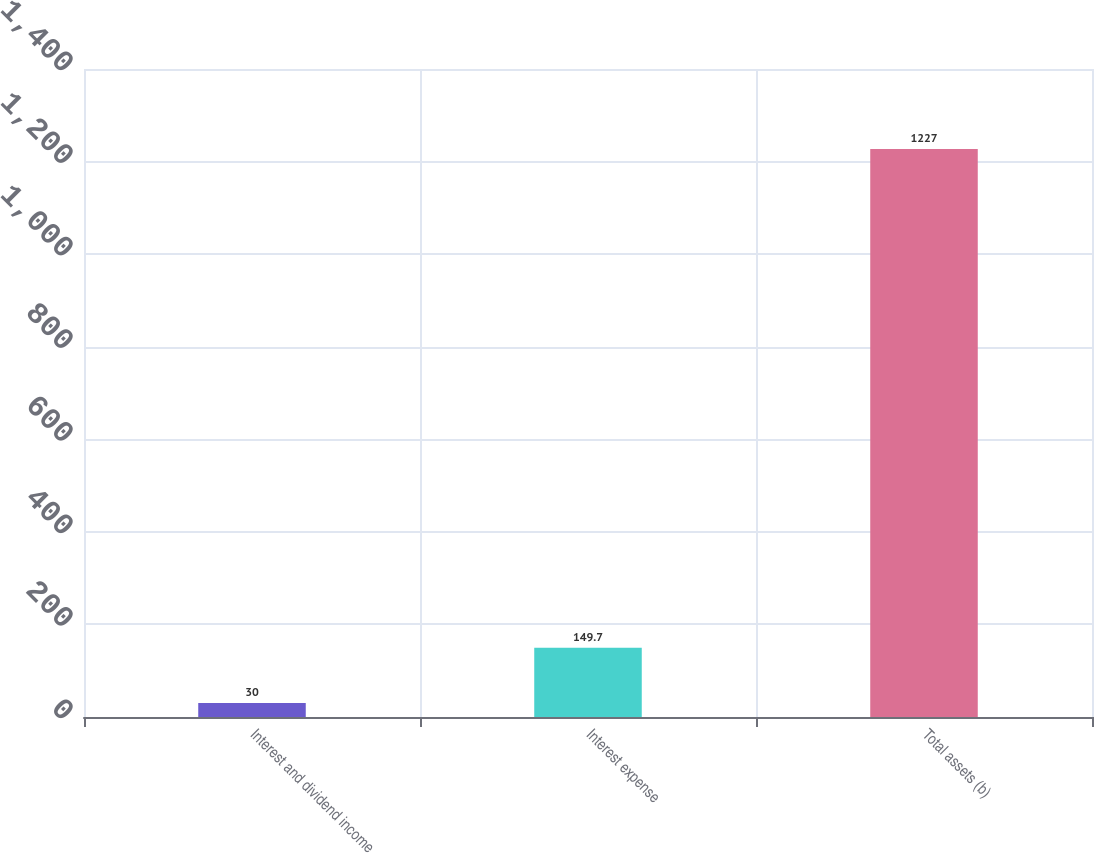Convert chart. <chart><loc_0><loc_0><loc_500><loc_500><bar_chart><fcel>Interest and dividend income<fcel>Interest expense<fcel>Total assets (b)<nl><fcel>30<fcel>149.7<fcel>1227<nl></chart> 